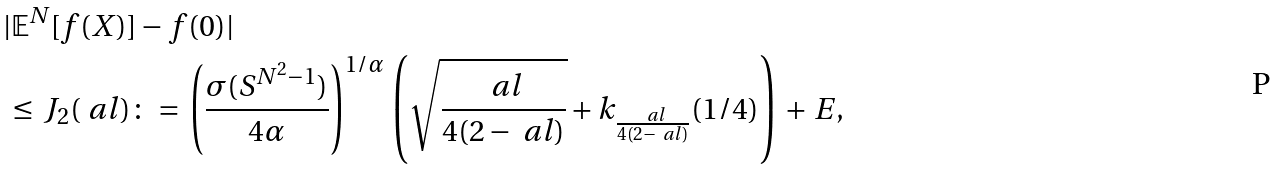Convert formula to latex. <formula><loc_0><loc_0><loc_500><loc_500>& | \mathbb { E } ^ { N } [ f ( X ) ] - f ( 0 ) | \\ & \, \leq \, J _ { 2 } ( \ a l ) \colon = \, \left ( \frac { \sigma ( S ^ { N ^ { 2 } - 1 } ) } { 4 \alpha } \right ) ^ { 1 / \alpha } \, \left ( \sqrt { \frac { \ a l } { 4 ( 2 - \ a l ) } } + k _ { \frac { \ a l } { 4 ( 2 - \ a l ) } } ( 1 / 4 ) \right ) \, + \, E ,</formula> 